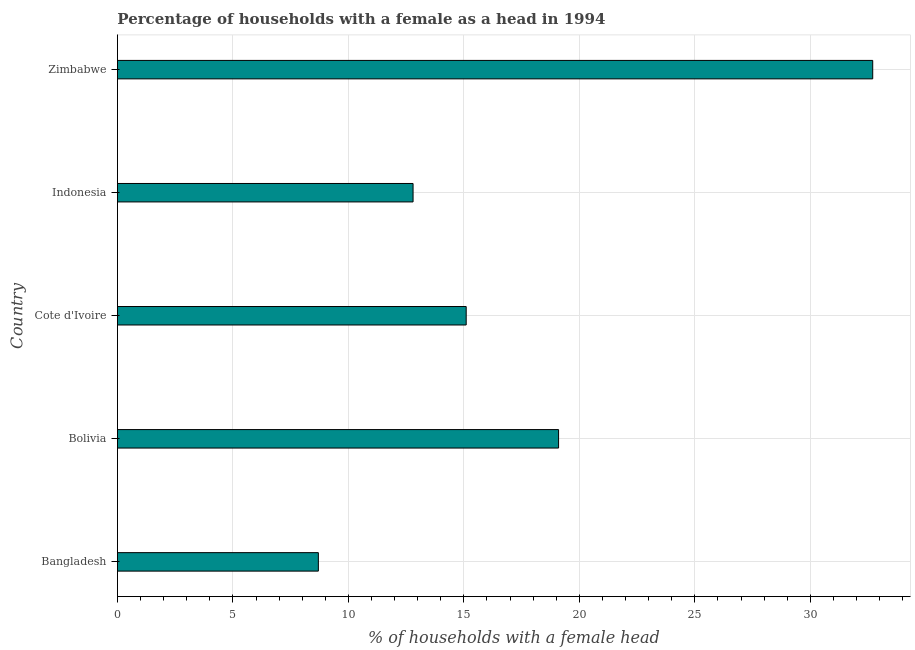Does the graph contain any zero values?
Provide a succinct answer. No. What is the title of the graph?
Provide a short and direct response. Percentage of households with a female as a head in 1994. What is the label or title of the X-axis?
Make the answer very short. % of households with a female head. What is the label or title of the Y-axis?
Make the answer very short. Country. Across all countries, what is the maximum number of female supervised households?
Give a very brief answer. 32.7. Across all countries, what is the minimum number of female supervised households?
Your answer should be compact. 8.7. In which country was the number of female supervised households maximum?
Provide a succinct answer. Zimbabwe. What is the sum of the number of female supervised households?
Your response must be concise. 88.4. What is the average number of female supervised households per country?
Your response must be concise. 17.68. What is the median number of female supervised households?
Your response must be concise. 15.1. In how many countries, is the number of female supervised households greater than 22 %?
Your answer should be very brief. 1. What is the ratio of the number of female supervised households in Bangladesh to that in Bolivia?
Ensure brevity in your answer.  0.46. Is the difference between the number of female supervised households in Bolivia and Indonesia greater than the difference between any two countries?
Give a very brief answer. No. Is the sum of the number of female supervised households in Bolivia and Cote d'Ivoire greater than the maximum number of female supervised households across all countries?
Provide a succinct answer. Yes. How many bars are there?
Your answer should be compact. 5. Are all the bars in the graph horizontal?
Your response must be concise. Yes. What is the difference between two consecutive major ticks on the X-axis?
Ensure brevity in your answer.  5. What is the % of households with a female head of Bolivia?
Ensure brevity in your answer.  19.1. What is the % of households with a female head of Cote d'Ivoire?
Provide a short and direct response. 15.1. What is the % of households with a female head in Zimbabwe?
Your response must be concise. 32.7. What is the difference between the % of households with a female head in Bangladesh and Bolivia?
Provide a succinct answer. -10.4. What is the difference between the % of households with a female head in Bangladesh and Cote d'Ivoire?
Your answer should be compact. -6.4. What is the difference between the % of households with a female head in Bolivia and Cote d'Ivoire?
Provide a succinct answer. 4. What is the difference between the % of households with a female head in Bolivia and Indonesia?
Give a very brief answer. 6.3. What is the difference between the % of households with a female head in Cote d'Ivoire and Zimbabwe?
Give a very brief answer. -17.6. What is the difference between the % of households with a female head in Indonesia and Zimbabwe?
Provide a short and direct response. -19.9. What is the ratio of the % of households with a female head in Bangladesh to that in Bolivia?
Ensure brevity in your answer.  0.46. What is the ratio of the % of households with a female head in Bangladesh to that in Cote d'Ivoire?
Offer a very short reply. 0.58. What is the ratio of the % of households with a female head in Bangladesh to that in Indonesia?
Make the answer very short. 0.68. What is the ratio of the % of households with a female head in Bangladesh to that in Zimbabwe?
Your answer should be very brief. 0.27. What is the ratio of the % of households with a female head in Bolivia to that in Cote d'Ivoire?
Offer a very short reply. 1.26. What is the ratio of the % of households with a female head in Bolivia to that in Indonesia?
Ensure brevity in your answer.  1.49. What is the ratio of the % of households with a female head in Bolivia to that in Zimbabwe?
Make the answer very short. 0.58. What is the ratio of the % of households with a female head in Cote d'Ivoire to that in Indonesia?
Keep it short and to the point. 1.18. What is the ratio of the % of households with a female head in Cote d'Ivoire to that in Zimbabwe?
Ensure brevity in your answer.  0.46. What is the ratio of the % of households with a female head in Indonesia to that in Zimbabwe?
Your answer should be compact. 0.39. 